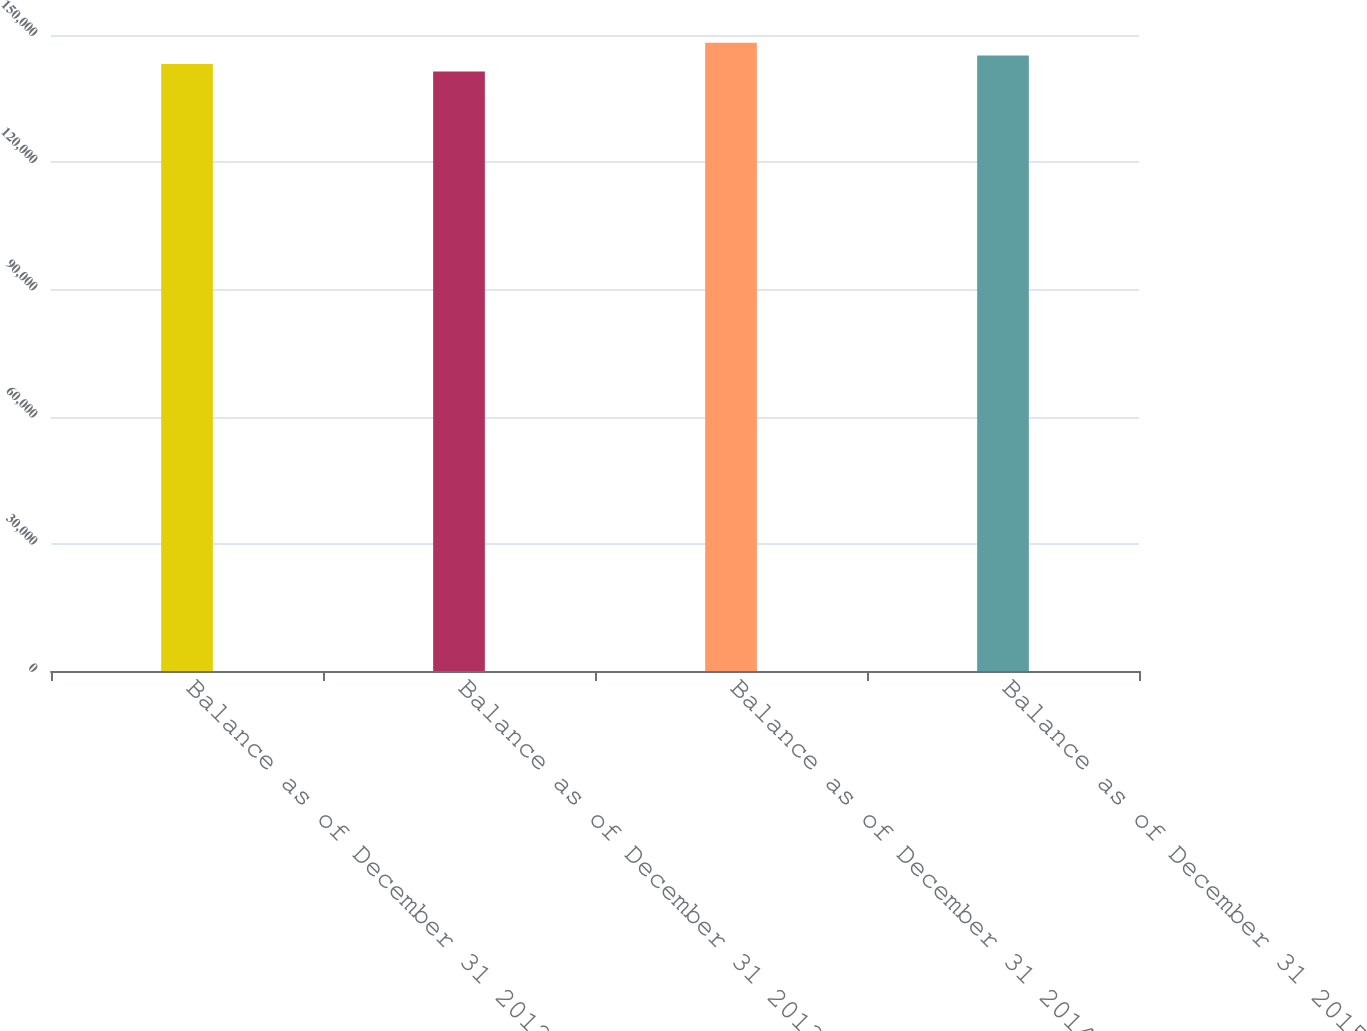Convert chart to OTSL. <chart><loc_0><loc_0><loc_500><loc_500><bar_chart><fcel>Balance as of December 31 2012<fcel>Balance as of December 31 2013<fcel>Balance as of December 31 2014<fcel>Balance as of December 31 2015<nl><fcel>143155<fcel>141408<fcel>148151<fcel>145191<nl></chart> 